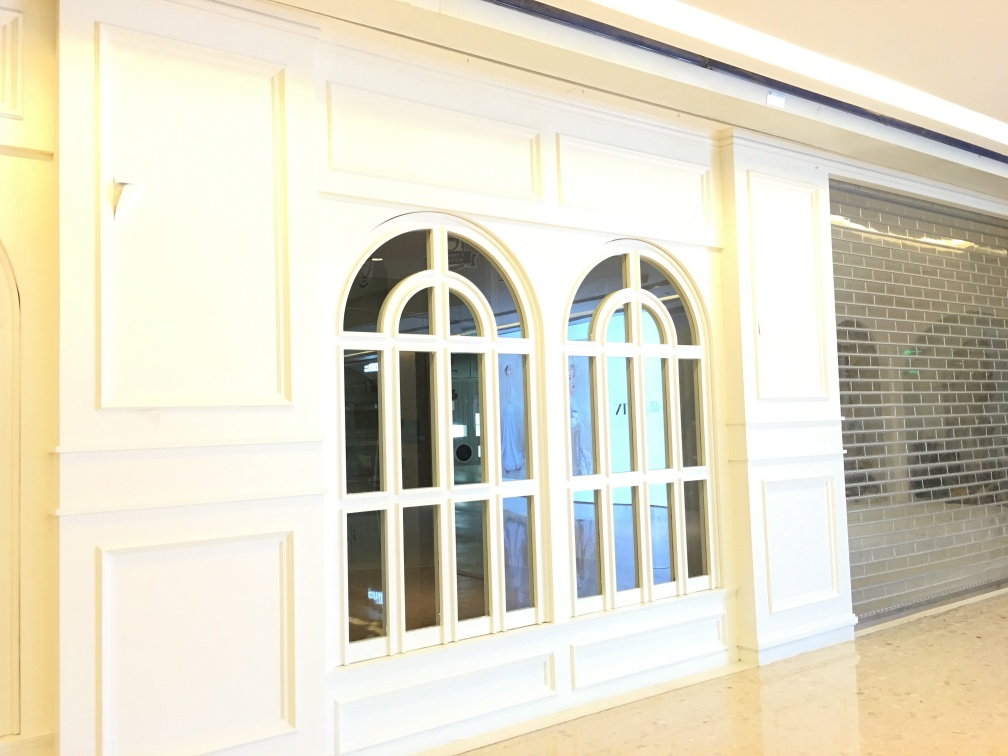What can be inferred about the function of this space? The space appears to be a public or semi-public area, such as a lobby or entrance hall, indicated by the wide, open tiled floor, the large windows for visibility, and the absence of any personal items which would suggest a more private setting. 